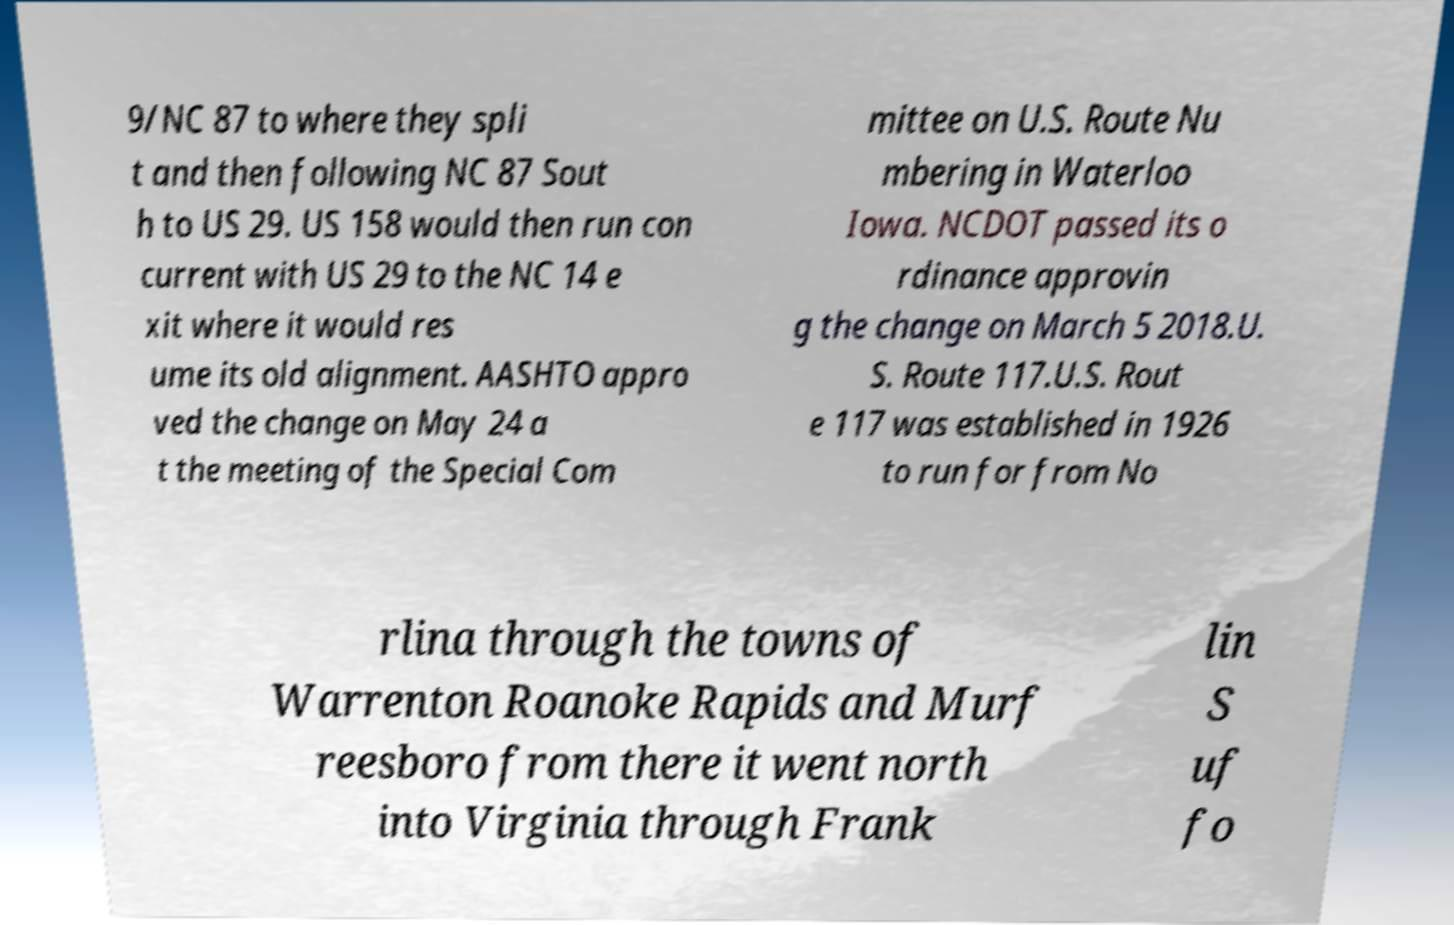I need the written content from this picture converted into text. Can you do that? 9/NC 87 to where they spli t and then following NC 87 Sout h to US 29. US 158 would then run con current with US 29 to the NC 14 e xit where it would res ume its old alignment. AASHTO appro ved the change on May 24 a t the meeting of the Special Com mittee on U.S. Route Nu mbering in Waterloo Iowa. NCDOT passed its o rdinance approvin g the change on March 5 2018.U. S. Route 117.U.S. Rout e 117 was established in 1926 to run for from No rlina through the towns of Warrenton Roanoke Rapids and Murf reesboro from there it went north into Virginia through Frank lin S uf fo 